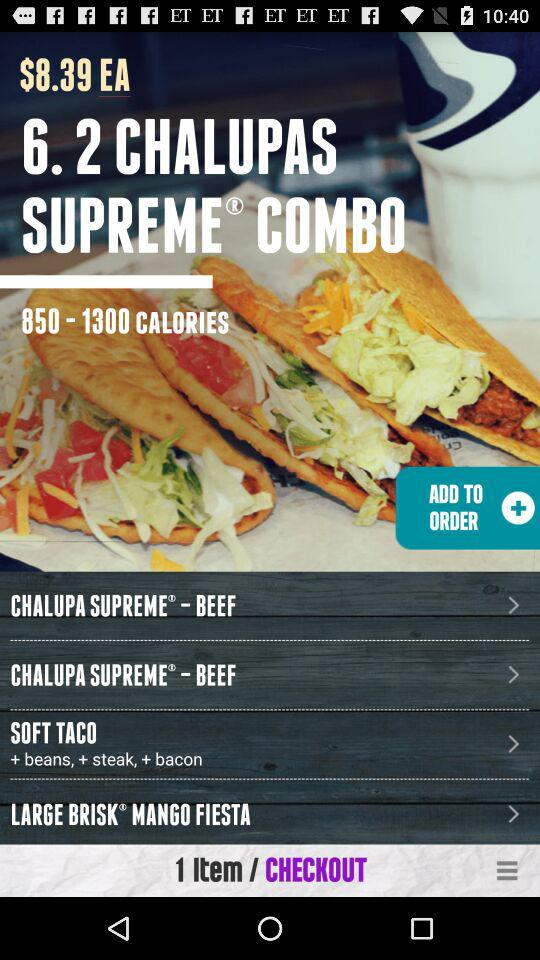What's in the menu? The items in the menu are "CHALUPA SUPREME - BEEF", "CHALUPA SUPREME - BEEF", "SOFT TACO" and "LARGE BRISK MANGO FIESTA". 